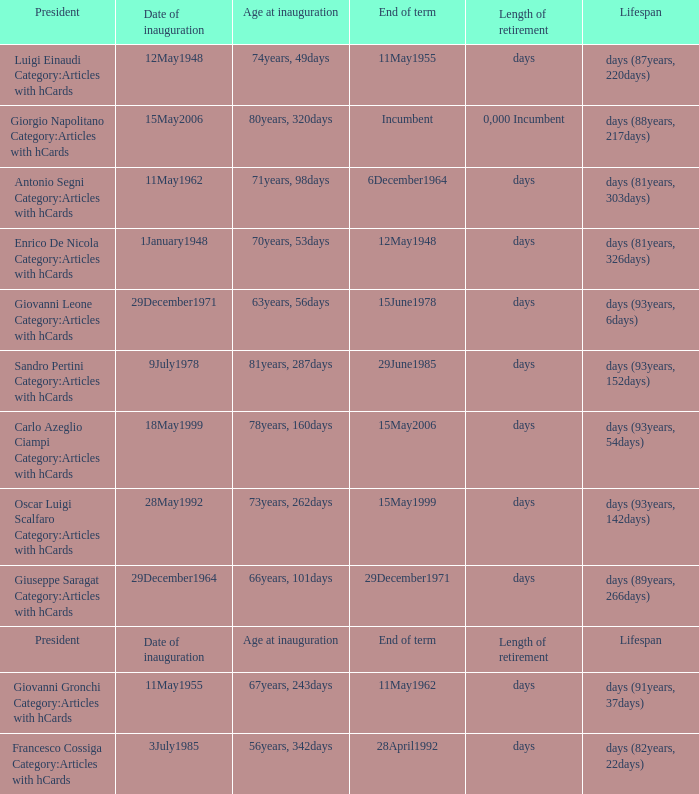What is the Date of inauguration of the President with an Age at inauguration of 73years, 262days? 28May1992. 